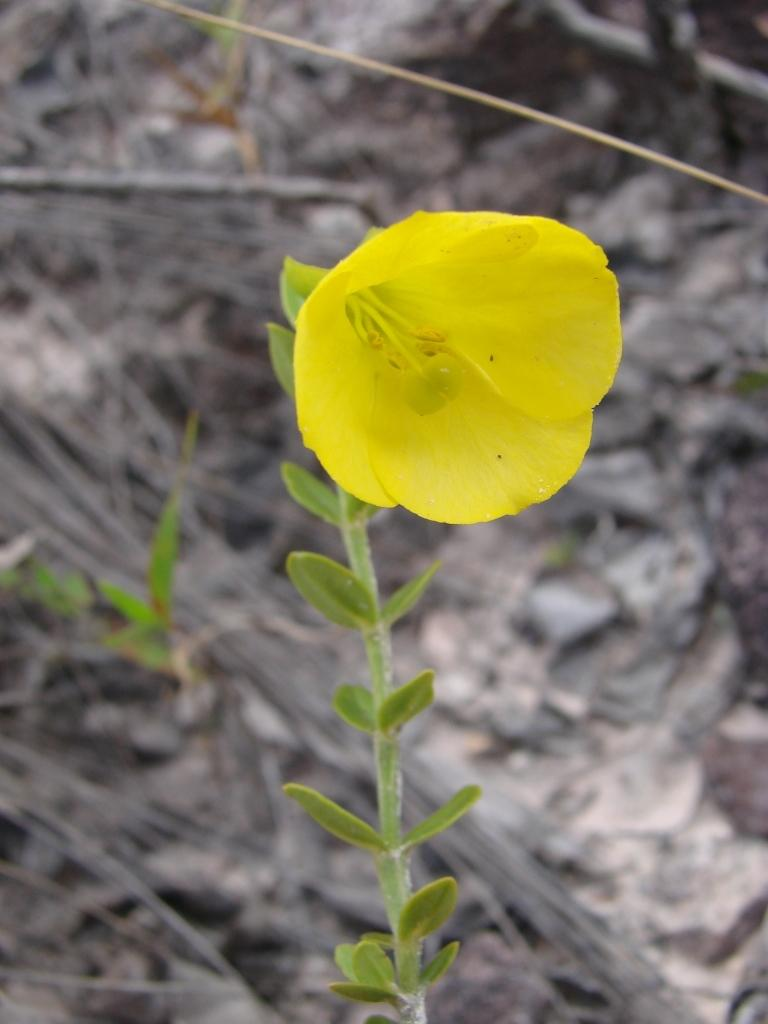What is the main subject of the image? There is a flower in the image. Where is the flower located? The flower is on a plant. What color is the flower? The flower is yellow in color. How would you describe the background of the image? The background of the image is black and white. Is there a tray filled with glue next to the flower in the image? No, there is no tray or glue present in the image. The image only features a yellow flower on a plant with a black and white background. 